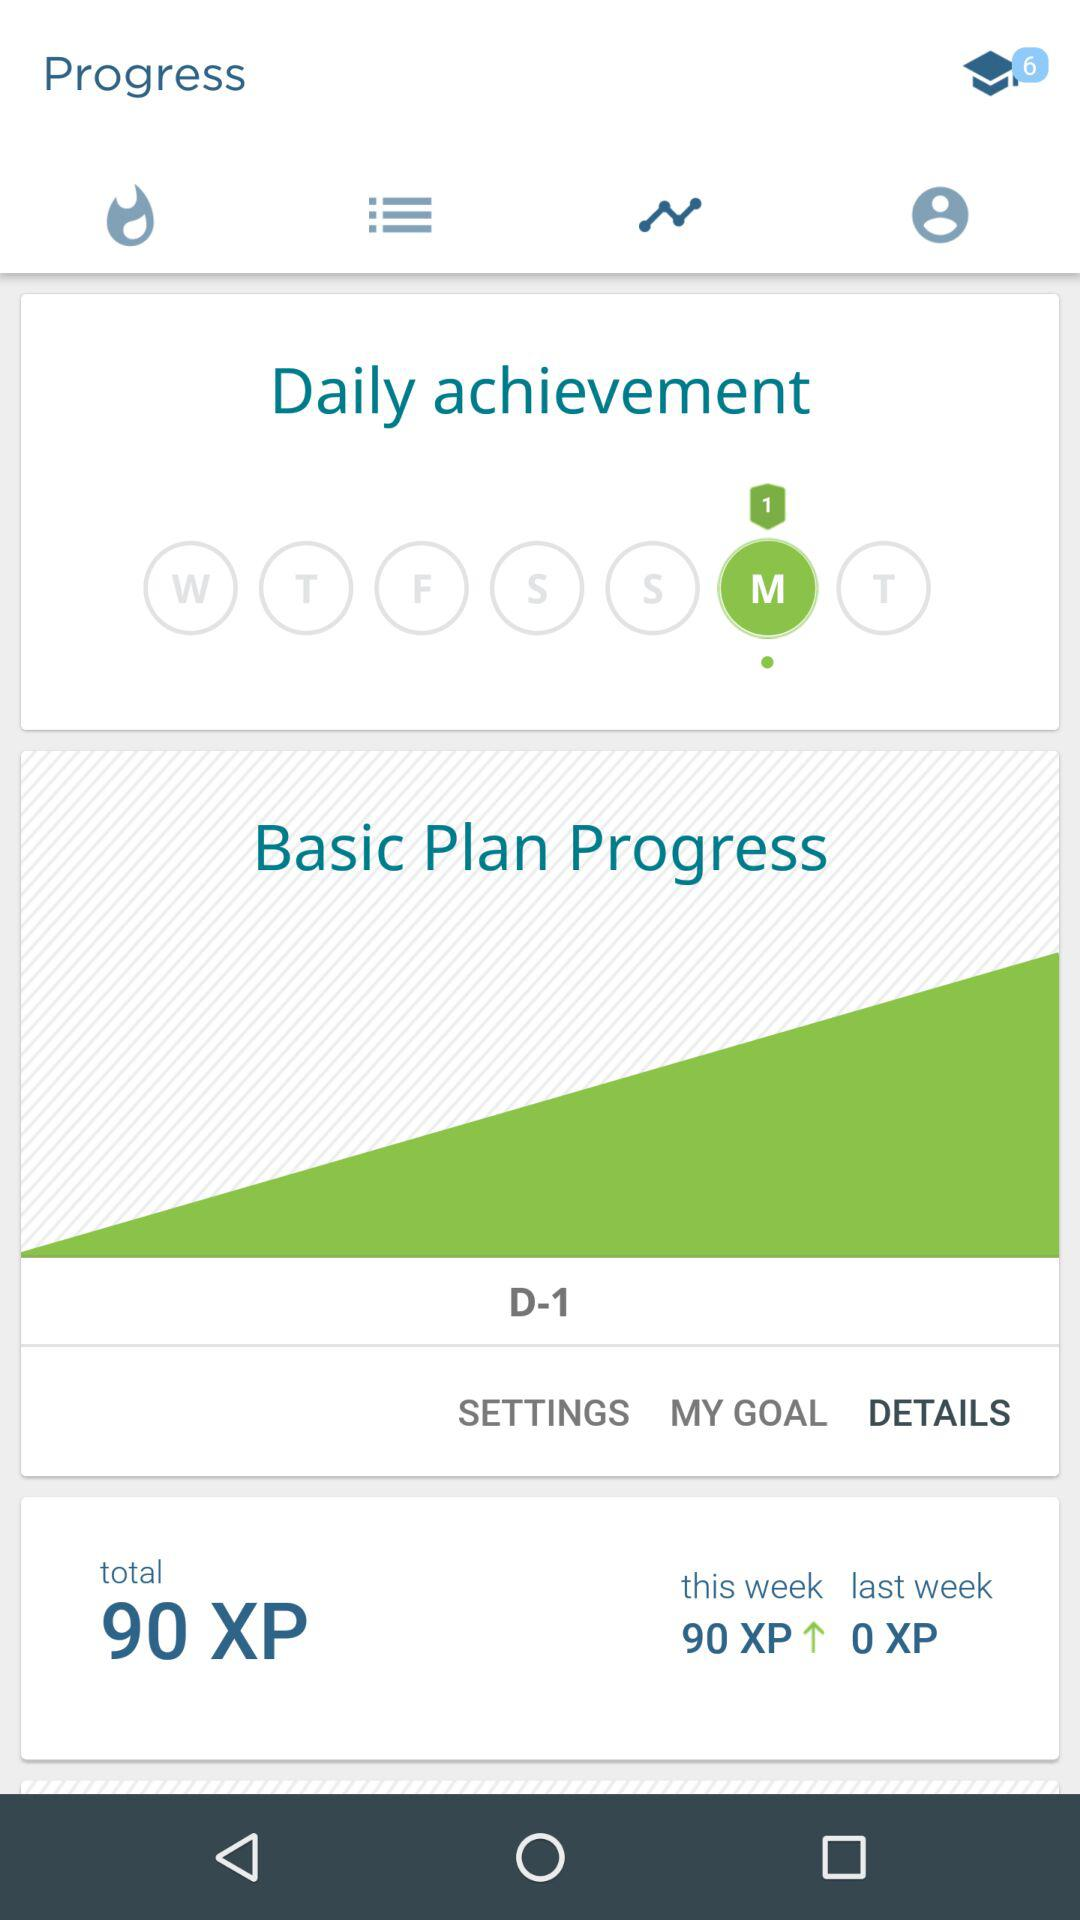How many days are left in my current plan?
Answer the question using a single word or phrase. 1 